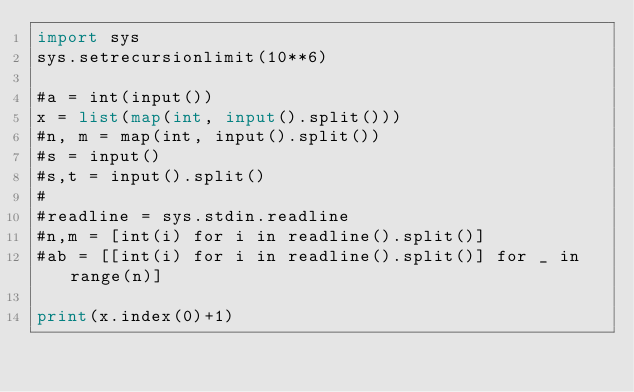Convert code to text. <code><loc_0><loc_0><loc_500><loc_500><_Python_>import sys
sys.setrecursionlimit(10**6)

#a = int(input())
x = list(map(int, input().split()))
#n, m = map(int, input().split())
#s = input()
#s,t = input().split()
#
#readline = sys.stdin.readline
#n,m = [int(i) for i in readline().split()]
#ab = [[int(i) for i in readline().split()] for _ in range(n)]

print(x.index(0)+1)</code> 